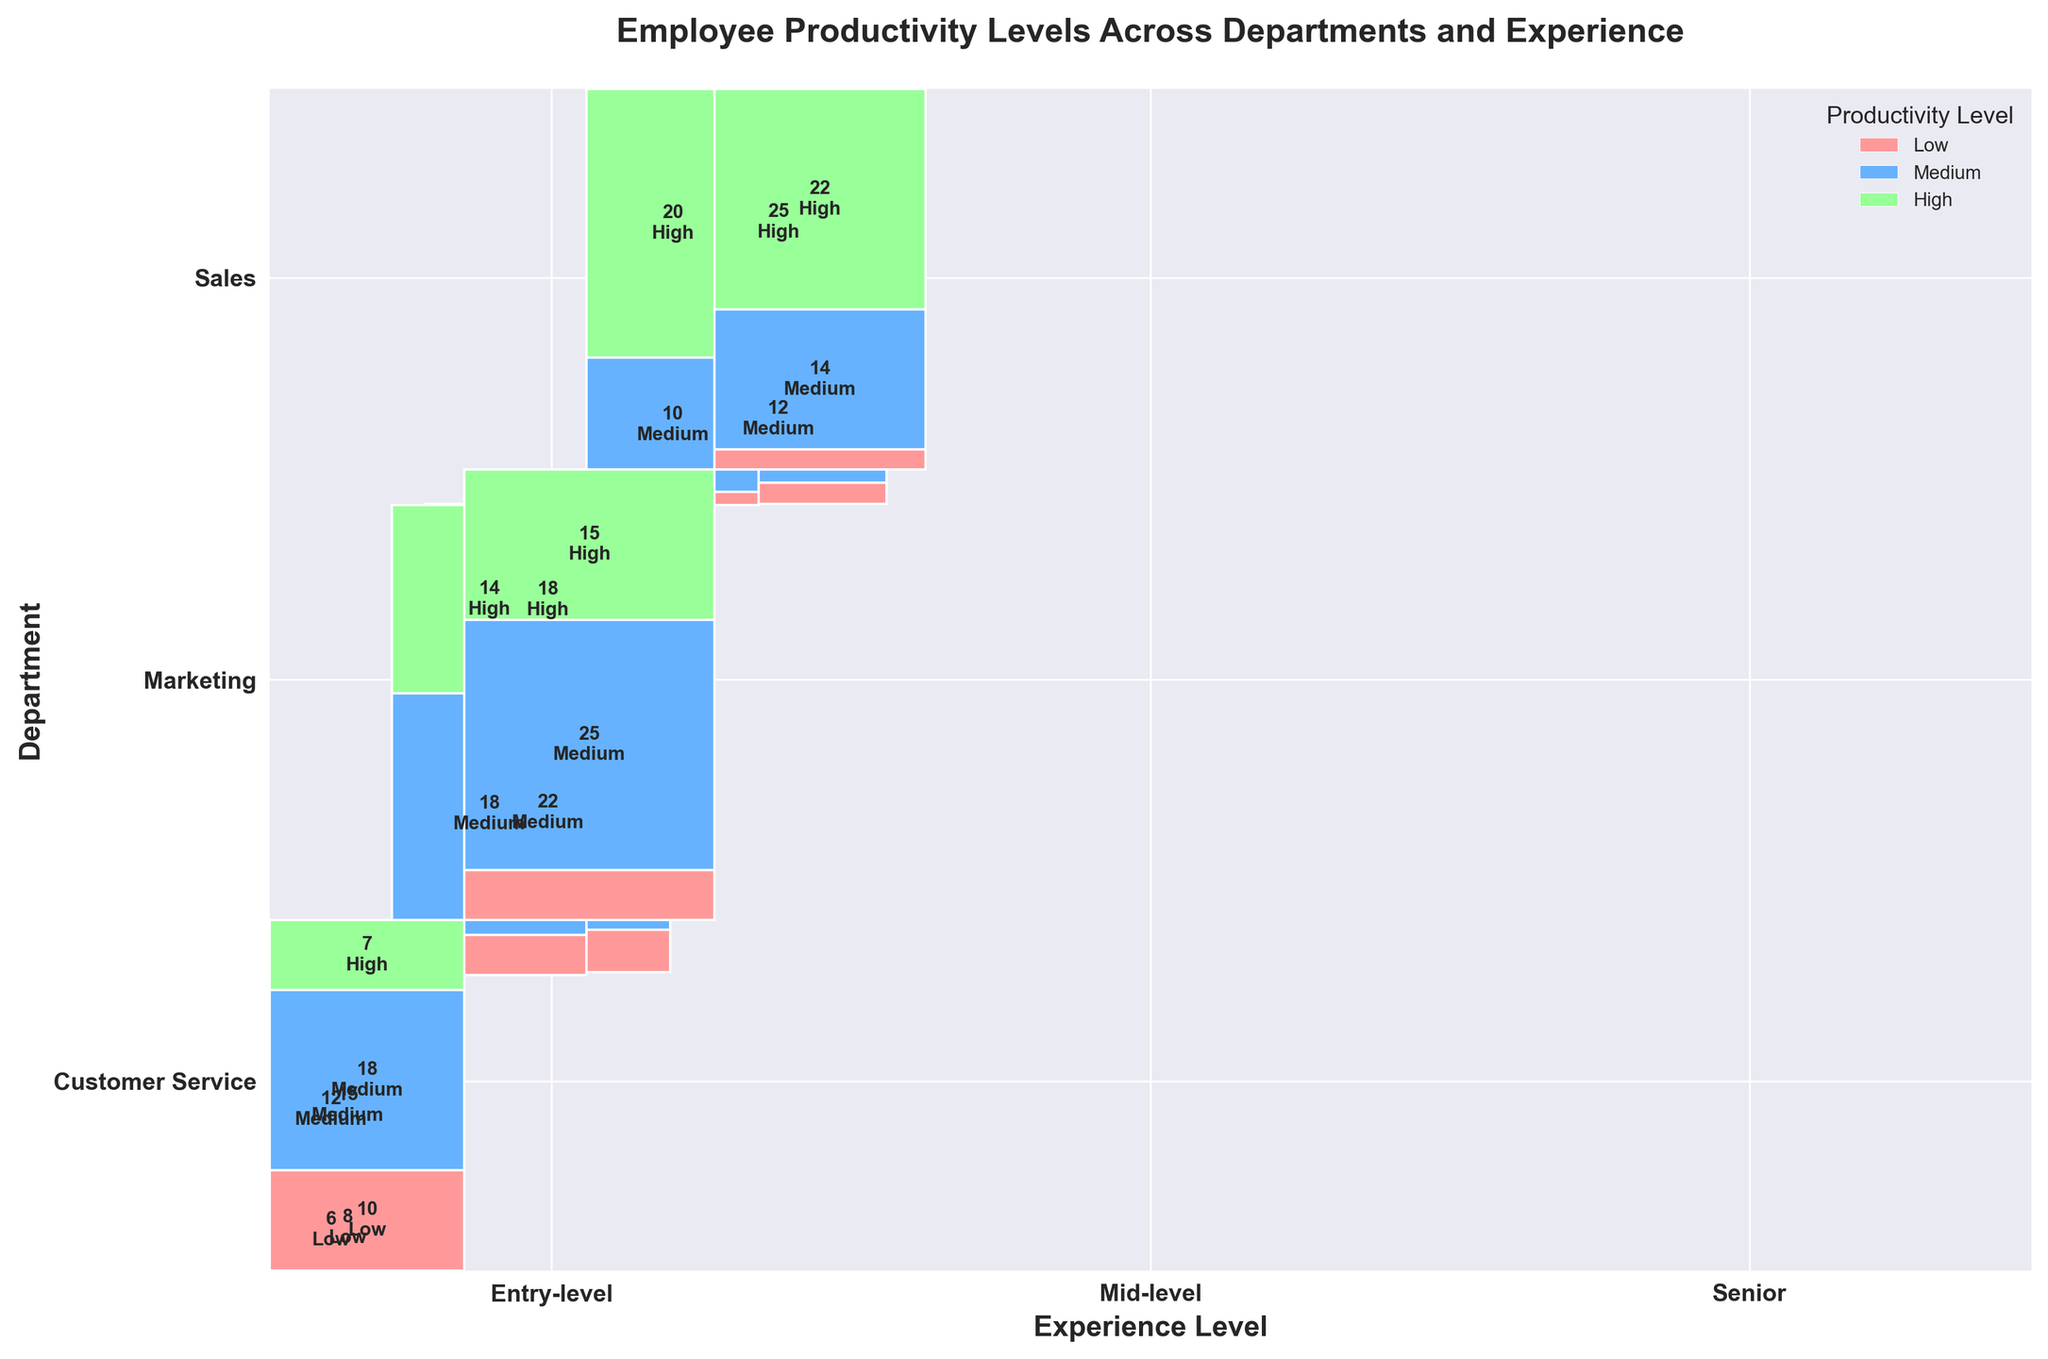What is the title of the mosaic plot? The title is generally placed at the top center of the plot. From the description provided, we know the title of the plotted figure.
Answer: Employee Productivity Levels Across Departments and Experience Which department has the highest number of high productivity employees regardless of experience level? To determine this, we need to look at the section of the plot corresponding to 'High' productivity for each department and identify which one covers the largest area vertically.
Answer: Sales How does the productivity level of senior employees in Customer Service compare to those in Sales? We observe the height of the sections for 'Senior' experience level in both 'Customer Service' and 'Sales' departments focusing on 'High' productivity. The block in Customer Service appears smaller than in Sales.
Answer: Higher in Sales What is the total number of medium productivity employees in marketing? Summarize the counts for 'Medium' productivity across all experience levels in the Marketing department by observing the values given inside the respective rectangles.
Answer: 40 (12 + 18 + 10) Which experience level has the most significant contribution to high productivity in the Marketing department? Look for the 'High' productivity sections in the 'Marketing' department column and compare the different rectangles for Entry-level, Mid-level, and Senior experience levels.
Answer: Senior Are there any departments where low productivity is more common than medium or high productivity? To answer this, check each department to see if the area covered by 'Low' productivity is larger than 'Medium' or 'High'.
Answer: No In Sales, which experience level has the least number of low productivity employees? Investigate the 'Low' productivity sections in the Sales department and find the smallest rectangle among Entry-level, Mid-level, and Senior experience levels.
Answer: Senior Compare the total number of high productivity employees in Customer Service and Marketing. Which department has more? Sum the counts of 'High' productivity for all experience levels in both Customer Service and Marketing and compare the totals.
Answer: Customer Service (22 + 15 + 7 = 44 vs 20 + 14 + 4 = 38) What is the distribution of productivity levels among entry-level employees across all departments? Observe the count for 'Low', 'Medium', and 'High' productivity levels for Entry-level employees in each department and list them.
Answer: Sales: 8 (Low), 15 (Medium), 5 (High); Marketing: 6 (Low), 12 (Medium), 4 (High); Customer Service: 10 (Low), 18 (Medium), 7 (High) In terms of medium productivity, which experience level in the Customer Service department has the highest number of employees? Look for all the areas labeled as 'Medium' productivity in the Customer Service section and identify the largest one among Entry-level, Mid-level, and Senior.
Answer: Mid-level 